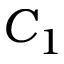Convert formula to latex. <formula><loc_0><loc_0><loc_500><loc_500>C _ { 1 }</formula> 